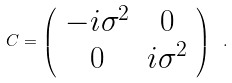<formula> <loc_0><loc_0><loc_500><loc_500>C = \left ( \begin{array} { c c } - i \sigma ^ { 2 } & 0 \\ 0 & i \sigma ^ { 2 } \end{array} \right ) \ .</formula> 